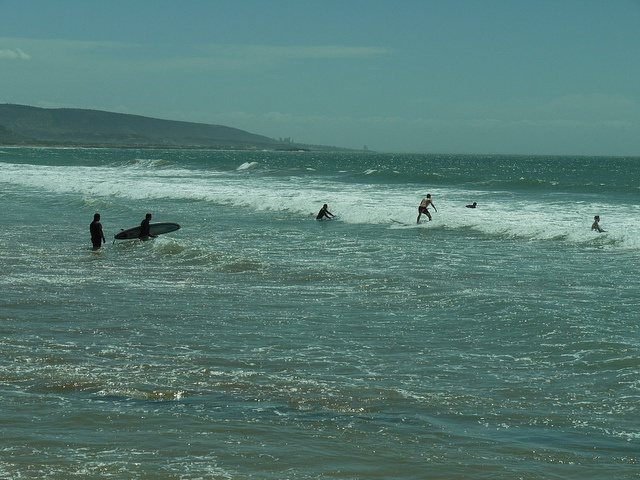Describe the objects in this image and their specific colors. I can see surfboard in teal and black tones, people in teal and black tones, people in teal and black tones, people in teal, black, gray, darkgray, and darkgreen tones, and people in teal, black, darkgray, and purple tones in this image. 